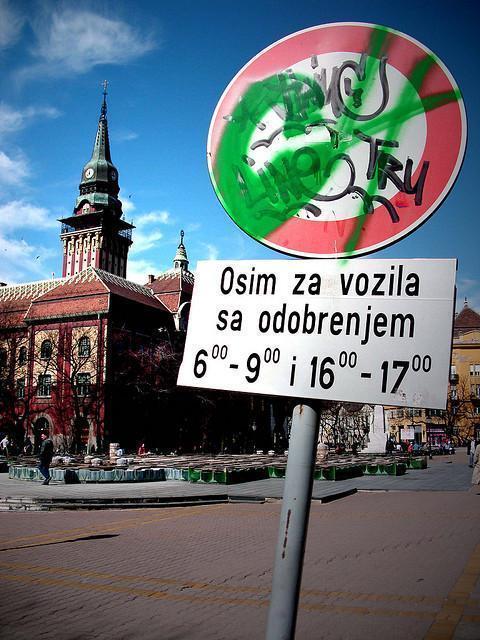What are the green markings an example of?
Make your selection and explain in format: 'Answer: answer
Rationale: rationale.'
Options: Art, typing, mural, graffiti. Answer: graffiti.
Rationale: The green markings are that of hoodlums vandalizing street signs. 